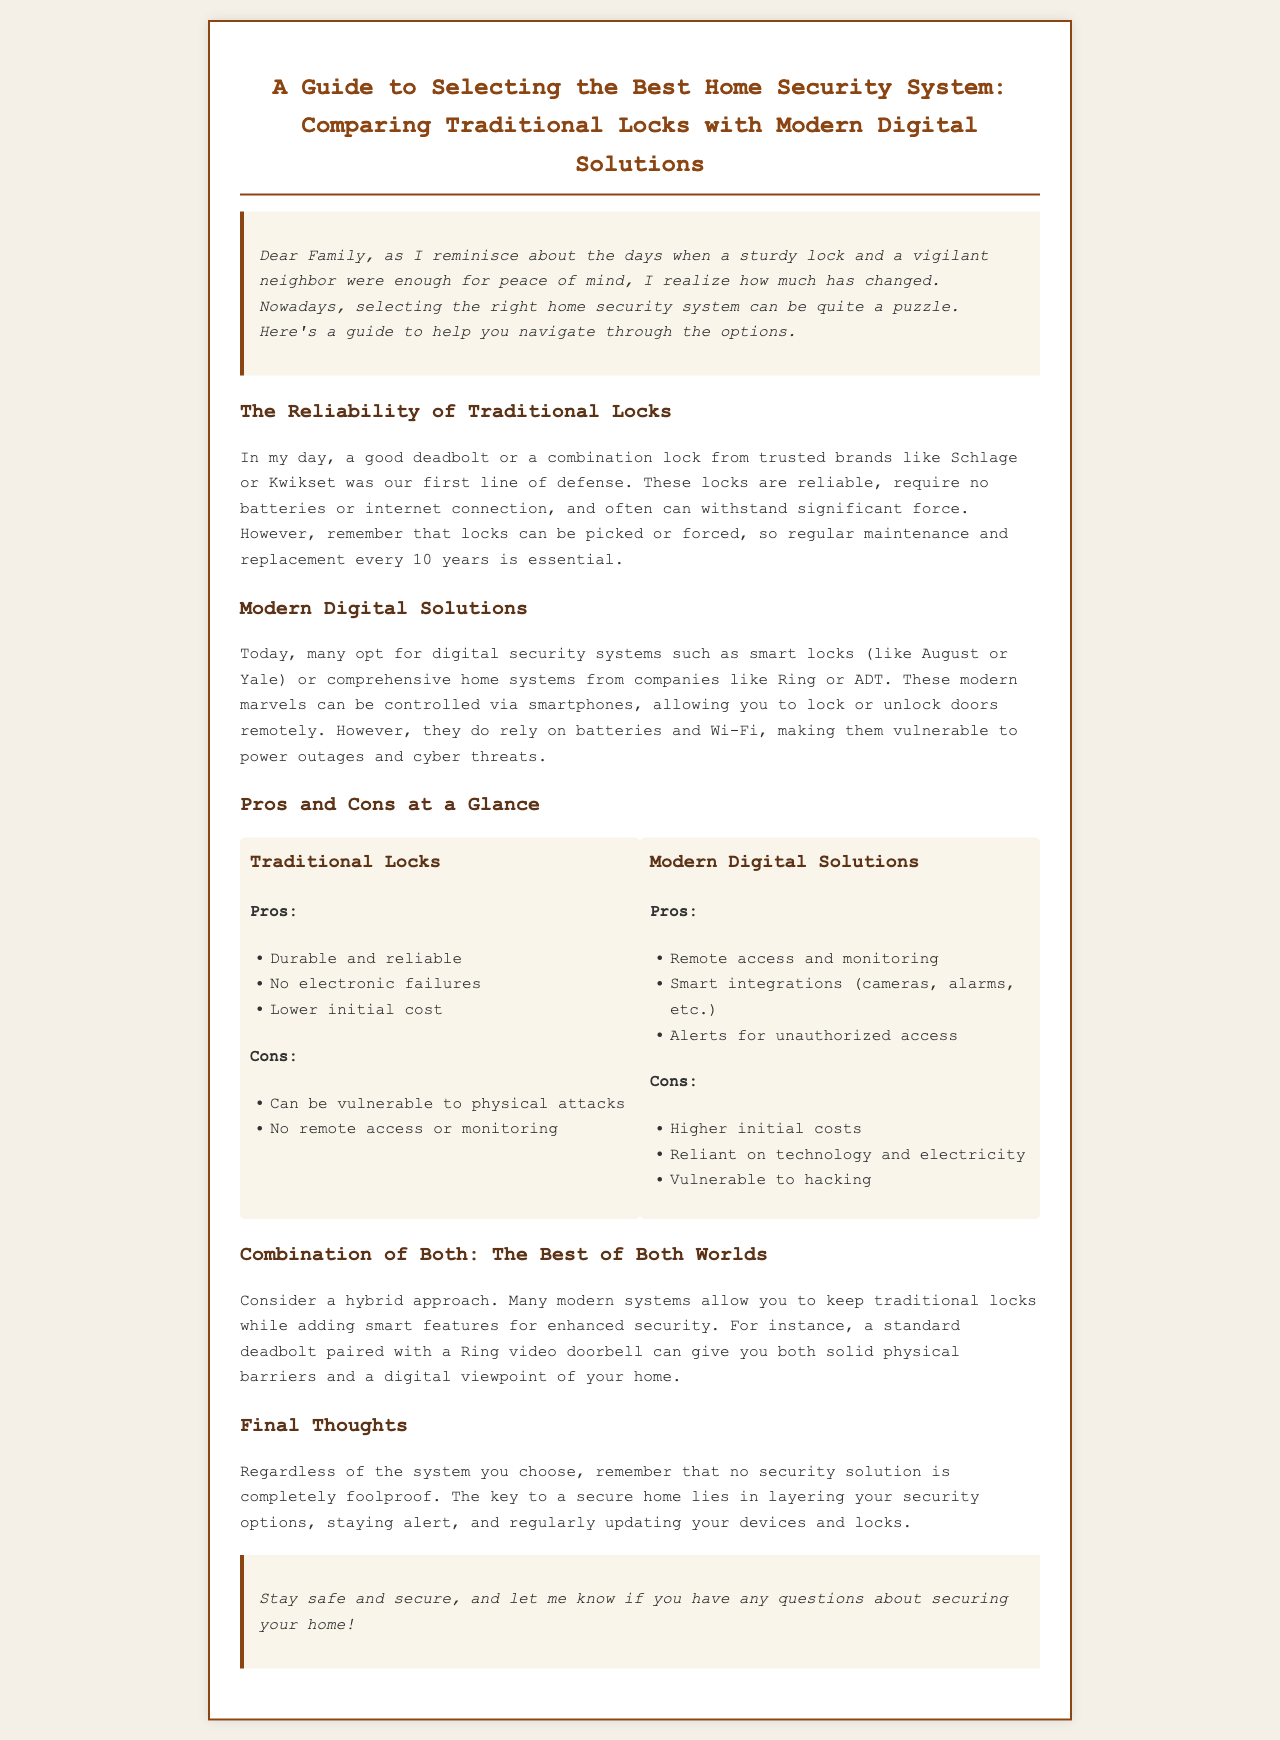What is the title of the newsletter? The title of the newsletter is stated at the top of the document.
Answer: A Guide to Selecting the Best Home Security System: Comparing Traditional Locks with Modern Digital Solutions What are two traditional lock brands mentioned? The document lists two specific brands of traditional locks that are considered trusted.
Answer: Schlage and Kwikset What is a modern digital solution mentioned in the newsletter? The document highlights a few examples of modern digital lock solutions.
Answer: August or Yale How long should traditional locks be maintained or replaced? The newsletter specifies a maintenance timeline for traditional locks.
Answer: Every 10 years What is a pro of modern digital solutions? The document outlines several advantages of modern digital security systems.
Answer: Remote access and monitoring What is a con of traditional locks? The document lists a specific drawback of relying solely on traditional locks.
Answer: Can be vulnerable to physical attacks What is a hybrid approach in home security? The document describes a method combining different types of security solutions.
Answer: Keeping traditional locks while adding smart features What is emphasized as essential for home security? The newsletter concludes with a key aspect necessary for maintaining secure premises.
Answer: Layering your security options 